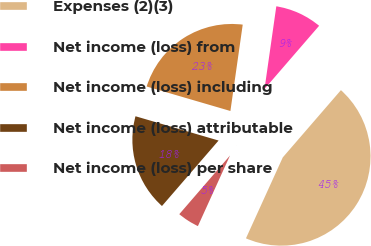Convert chart. <chart><loc_0><loc_0><loc_500><loc_500><pie_chart><fcel>Expenses (2)(3)<fcel>Net income (loss) from<fcel>Net income (loss) including<fcel>Net income (loss) attributable<fcel>Net income (loss) per share<nl><fcel>45.45%<fcel>9.09%<fcel>22.73%<fcel>18.18%<fcel>4.55%<nl></chart> 